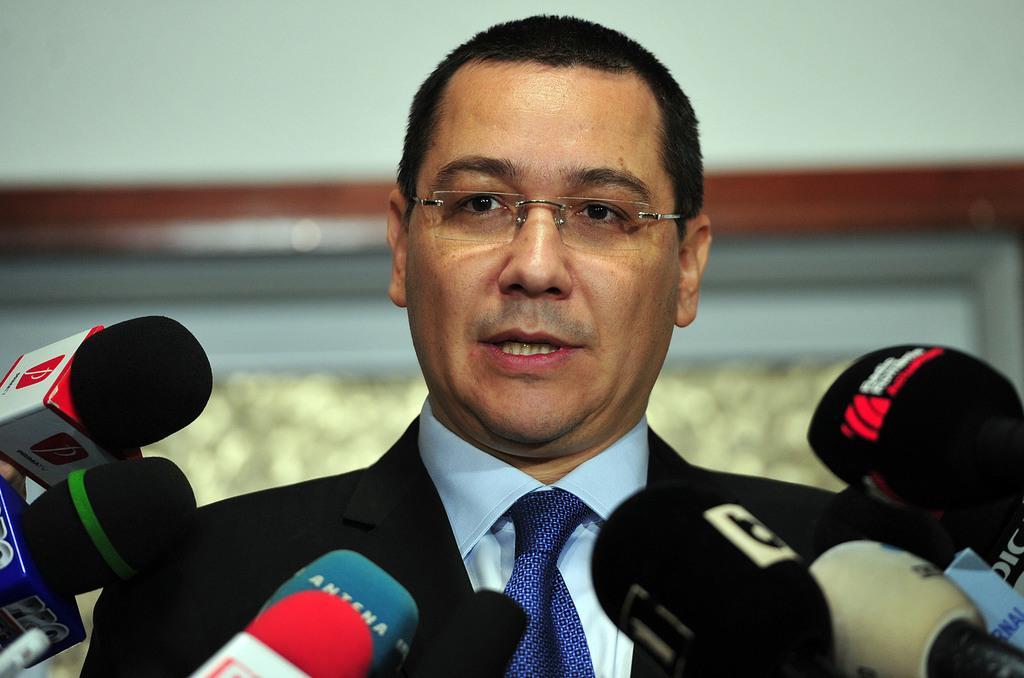Describe this image in one or two sentences. In this image, we can see a man in a suit is talking and wearing glasses. At the bottom, we can see few microphones. Background there is a blur view. Here we can see a white color. 